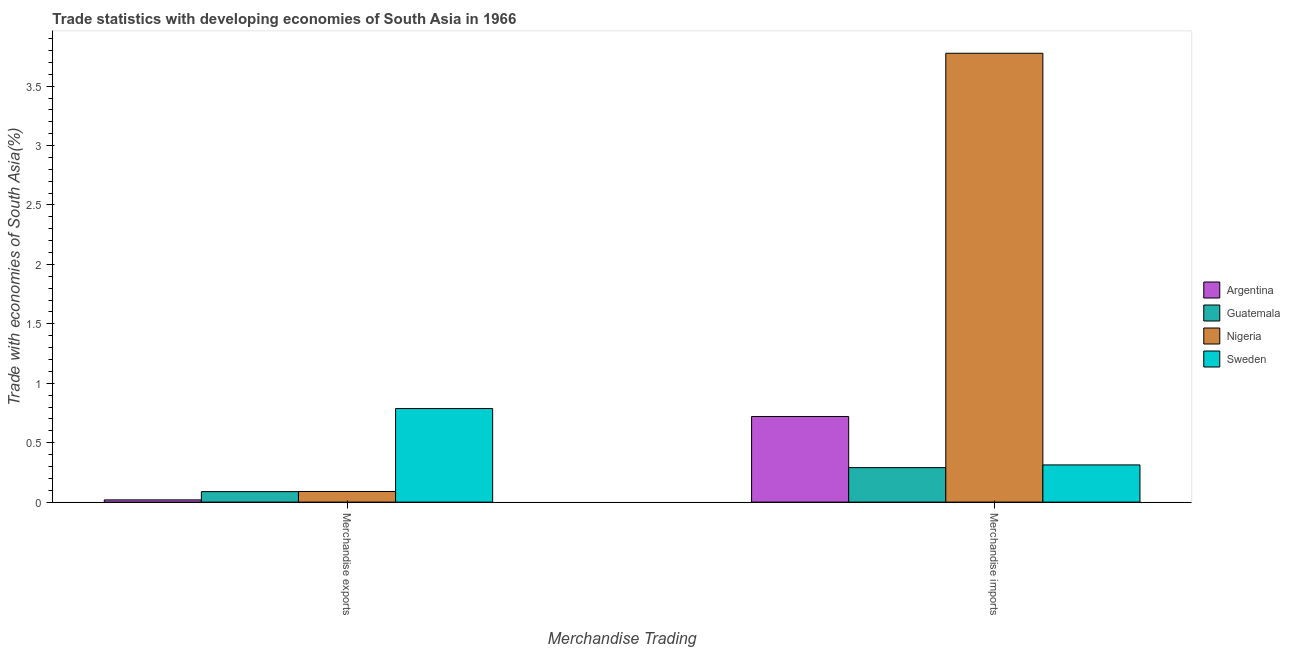How many different coloured bars are there?
Provide a succinct answer. 4. How many groups of bars are there?
Make the answer very short. 2. Are the number of bars per tick equal to the number of legend labels?
Ensure brevity in your answer.  Yes. How many bars are there on the 2nd tick from the left?
Ensure brevity in your answer.  4. What is the label of the 2nd group of bars from the left?
Your answer should be very brief. Merchandise imports. What is the merchandise exports in Argentina?
Keep it short and to the point. 0.02. Across all countries, what is the maximum merchandise exports?
Provide a succinct answer. 0.79. Across all countries, what is the minimum merchandise exports?
Offer a terse response. 0.02. In which country was the merchandise imports maximum?
Provide a succinct answer. Nigeria. In which country was the merchandise imports minimum?
Ensure brevity in your answer.  Guatemala. What is the total merchandise exports in the graph?
Make the answer very short. 0.98. What is the difference between the merchandise exports in Guatemala and that in Nigeria?
Give a very brief answer. -0. What is the difference between the merchandise exports in Sweden and the merchandise imports in Argentina?
Make the answer very short. 0.07. What is the average merchandise exports per country?
Keep it short and to the point. 0.25. What is the difference between the merchandise imports and merchandise exports in Nigeria?
Your answer should be very brief. 3.69. In how many countries, is the merchandise exports greater than 0.4 %?
Offer a terse response. 1. What is the ratio of the merchandise exports in Nigeria to that in Guatemala?
Provide a succinct answer. 1.01. In how many countries, is the merchandise imports greater than the average merchandise imports taken over all countries?
Ensure brevity in your answer.  1. What does the 4th bar from the left in Merchandise imports represents?
Your answer should be compact. Sweden. What does the 4th bar from the right in Merchandise exports represents?
Provide a short and direct response. Argentina. Are all the bars in the graph horizontal?
Ensure brevity in your answer.  No. How many countries are there in the graph?
Provide a succinct answer. 4. What is the difference between two consecutive major ticks on the Y-axis?
Offer a very short reply. 0.5. Are the values on the major ticks of Y-axis written in scientific E-notation?
Give a very brief answer. No. Does the graph contain grids?
Offer a terse response. No. What is the title of the graph?
Give a very brief answer. Trade statistics with developing economies of South Asia in 1966. Does "Caribbean small states" appear as one of the legend labels in the graph?
Your answer should be compact. No. What is the label or title of the X-axis?
Your answer should be very brief. Merchandise Trading. What is the label or title of the Y-axis?
Make the answer very short. Trade with economies of South Asia(%). What is the Trade with economies of South Asia(%) in Argentina in Merchandise exports?
Offer a terse response. 0.02. What is the Trade with economies of South Asia(%) of Guatemala in Merchandise exports?
Provide a succinct answer. 0.09. What is the Trade with economies of South Asia(%) in Nigeria in Merchandise exports?
Provide a short and direct response. 0.09. What is the Trade with economies of South Asia(%) in Sweden in Merchandise exports?
Your response must be concise. 0.79. What is the Trade with economies of South Asia(%) of Argentina in Merchandise imports?
Your response must be concise. 0.72. What is the Trade with economies of South Asia(%) in Guatemala in Merchandise imports?
Your answer should be very brief. 0.29. What is the Trade with economies of South Asia(%) of Nigeria in Merchandise imports?
Your answer should be compact. 3.78. What is the Trade with economies of South Asia(%) in Sweden in Merchandise imports?
Make the answer very short. 0.31. Across all Merchandise Trading, what is the maximum Trade with economies of South Asia(%) of Argentina?
Make the answer very short. 0.72. Across all Merchandise Trading, what is the maximum Trade with economies of South Asia(%) of Guatemala?
Provide a short and direct response. 0.29. Across all Merchandise Trading, what is the maximum Trade with economies of South Asia(%) in Nigeria?
Provide a short and direct response. 3.78. Across all Merchandise Trading, what is the maximum Trade with economies of South Asia(%) of Sweden?
Provide a short and direct response. 0.79. Across all Merchandise Trading, what is the minimum Trade with economies of South Asia(%) of Argentina?
Ensure brevity in your answer.  0.02. Across all Merchandise Trading, what is the minimum Trade with economies of South Asia(%) in Guatemala?
Offer a terse response. 0.09. Across all Merchandise Trading, what is the minimum Trade with economies of South Asia(%) of Nigeria?
Provide a succinct answer. 0.09. Across all Merchandise Trading, what is the minimum Trade with economies of South Asia(%) in Sweden?
Your response must be concise. 0.31. What is the total Trade with economies of South Asia(%) in Argentina in the graph?
Offer a very short reply. 0.74. What is the total Trade with economies of South Asia(%) of Guatemala in the graph?
Ensure brevity in your answer.  0.38. What is the total Trade with economies of South Asia(%) in Nigeria in the graph?
Your answer should be very brief. 3.87. What is the total Trade with economies of South Asia(%) of Sweden in the graph?
Your answer should be compact. 1.1. What is the difference between the Trade with economies of South Asia(%) in Argentina in Merchandise exports and that in Merchandise imports?
Provide a succinct answer. -0.7. What is the difference between the Trade with economies of South Asia(%) of Guatemala in Merchandise exports and that in Merchandise imports?
Give a very brief answer. -0.2. What is the difference between the Trade with economies of South Asia(%) of Nigeria in Merchandise exports and that in Merchandise imports?
Make the answer very short. -3.69. What is the difference between the Trade with economies of South Asia(%) in Sweden in Merchandise exports and that in Merchandise imports?
Make the answer very short. 0.47. What is the difference between the Trade with economies of South Asia(%) of Argentina in Merchandise exports and the Trade with economies of South Asia(%) of Guatemala in Merchandise imports?
Provide a short and direct response. -0.27. What is the difference between the Trade with economies of South Asia(%) of Argentina in Merchandise exports and the Trade with economies of South Asia(%) of Nigeria in Merchandise imports?
Provide a short and direct response. -3.76. What is the difference between the Trade with economies of South Asia(%) of Argentina in Merchandise exports and the Trade with economies of South Asia(%) of Sweden in Merchandise imports?
Offer a very short reply. -0.29. What is the difference between the Trade with economies of South Asia(%) of Guatemala in Merchandise exports and the Trade with economies of South Asia(%) of Nigeria in Merchandise imports?
Offer a terse response. -3.69. What is the difference between the Trade with economies of South Asia(%) of Guatemala in Merchandise exports and the Trade with economies of South Asia(%) of Sweden in Merchandise imports?
Offer a terse response. -0.22. What is the difference between the Trade with economies of South Asia(%) of Nigeria in Merchandise exports and the Trade with economies of South Asia(%) of Sweden in Merchandise imports?
Provide a short and direct response. -0.22. What is the average Trade with economies of South Asia(%) of Argentina per Merchandise Trading?
Give a very brief answer. 0.37. What is the average Trade with economies of South Asia(%) in Guatemala per Merchandise Trading?
Your answer should be very brief. 0.19. What is the average Trade with economies of South Asia(%) in Nigeria per Merchandise Trading?
Ensure brevity in your answer.  1.93. What is the average Trade with economies of South Asia(%) of Sweden per Merchandise Trading?
Your answer should be very brief. 0.55. What is the difference between the Trade with economies of South Asia(%) of Argentina and Trade with economies of South Asia(%) of Guatemala in Merchandise exports?
Your answer should be compact. -0.07. What is the difference between the Trade with economies of South Asia(%) in Argentina and Trade with economies of South Asia(%) in Nigeria in Merchandise exports?
Offer a very short reply. -0.07. What is the difference between the Trade with economies of South Asia(%) of Argentina and Trade with economies of South Asia(%) of Sweden in Merchandise exports?
Give a very brief answer. -0.77. What is the difference between the Trade with economies of South Asia(%) of Guatemala and Trade with economies of South Asia(%) of Nigeria in Merchandise exports?
Your response must be concise. -0. What is the difference between the Trade with economies of South Asia(%) in Guatemala and Trade with economies of South Asia(%) in Sweden in Merchandise exports?
Your response must be concise. -0.7. What is the difference between the Trade with economies of South Asia(%) in Nigeria and Trade with economies of South Asia(%) in Sweden in Merchandise exports?
Make the answer very short. -0.7. What is the difference between the Trade with economies of South Asia(%) of Argentina and Trade with economies of South Asia(%) of Guatemala in Merchandise imports?
Your answer should be very brief. 0.43. What is the difference between the Trade with economies of South Asia(%) of Argentina and Trade with economies of South Asia(%) of Nigeria in Merchandise imports?
Your response must be concise. -3.06. What is the difference between the Trade with economies of South Asia(%) of Argentina and Trade with economies of South Asia(%) of Sweden in Merchandise imports?
Give a very brief answer. 0.41. What is the difference between the Trade with economies of South Asia(%) in Guatemala and Trade with economies of South Asia(%) in Nigeria in Merchandise imports?
Your answer should be compact. -3.49. What is the difference between the Trade with economies of South Asia(%) of Guatemala and Trade with economies of South Asia(%) of Sweden in Merchandise imports?
Keep it short and to the point. -0.02. What is the difference between the Trade with economies of South Asia(%) of Nigeria and Trade with economies of South Asia(%) of Sweden in Merchandise imports?
Make the answer very short. 3.46. What is the ratio of the Trade with economies of South Asia(%) in Argentina in Merchandise exports to that in Merchandise imports?
Ensure brevity in your answer.  0.03. What is the ratio of the Trade with economies of South Asia(%) in Guatemala in Merchandise exports to that in Merchandise imports?
Provide a short and direct response. 0.3. What is the ratio of the Trade with economies of South Asia(%) of Nigeria in Merchandise exports to that in Merchandise imports?
Offer a very short reply. 0.02. What is the ratio of the Trade with economies of South Asia(%) of Sweden in Merchandise exports to that in Merchandise imports?
Give a very brief answer. 2.51. What is the difference between the highest and the second highest Trade with economies of South Asia(%) in Argentina?
Provide a short and direct response. 0.7. What is the difference between the highest and the second highest Trade with economies of South Asia(%) in Guatemala?
Provide a succinct answer. 0.2. What is the difference between the highest and the second highest Trade with economies of South Asia(%) of Nigeria?
Make the answer very short. 3.69. What is the difference between the highest and the second highest Trade with economies of South Asia(%) in Sweden?
Offer a terse response. 0.47. What is the difference between the highest and the lowest Trade with economies of South Asia(%) of Argentina?
Your response must be concise. 0.7. What is the difference between the highest and the lowest Trade with economies of South Asia(%) in Guatemala?
Make the answer very short. 0.2. What is the difference between the highest and the lowest Trade with economies of South Asia(%) of Nigeria?
Give a very brief answer. 3.69. What is the difference between the highest and the lowest Trade with economies of South Asia(%) in Sweden?
Provide a short and direct response. 0.47. 